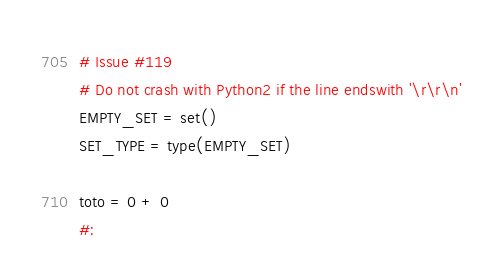Convert code to text. <code><loc_0><loc_0><loc_500><loc_500><_Python_>
# Issue #119
# Do not crash with Python2 if the line endswith '\r\r\n'
EMPTY_SET = set()
SET_TYPE = type(EMPTY_SET)
toto = 0 + 0
#:
</code> 